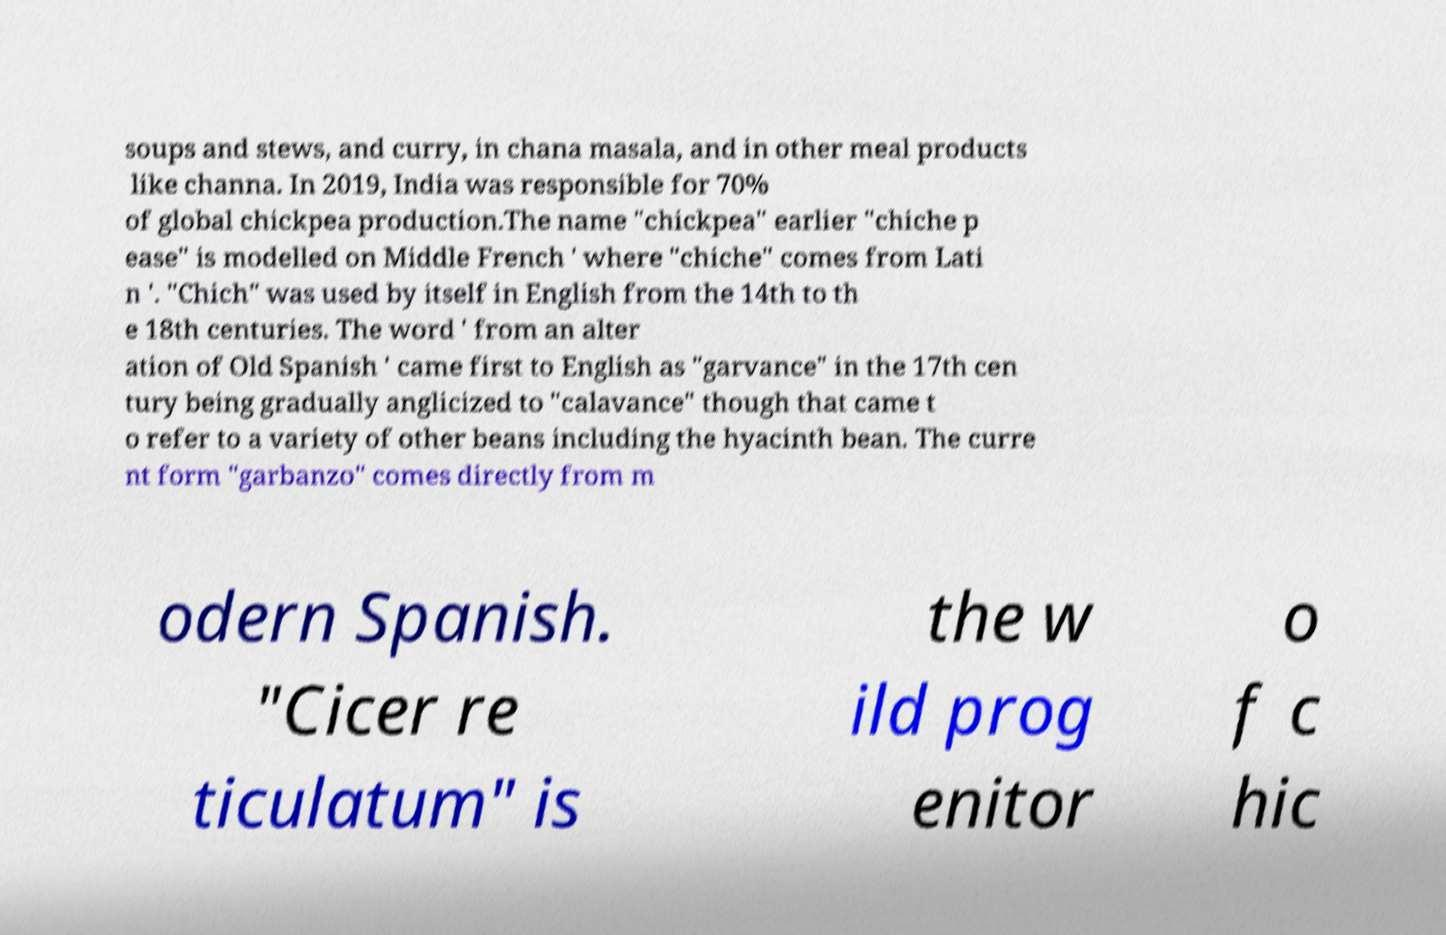Could you assist in decoding the text presented in this image and type it out clearly? soups and stews, and curry, in chana masala, and in other meal products like channa. In 2019, India was responsible for 70% of global chickpea production.The name "chickpea" earlier "chiche p ease" is modelled on Middle French ' where "chiche" comes from Lati n '. "Chich" was used by itself in English from the 14th to th e 18th centuries. The word ' from an alter ation of Old Spanish ' came first to English as "garvance" in the 17th cen tury being gradually anglicized to "calavance" though that came t o refer to a variety of other beans including the hyacinth bean. The curre nt form "garbanzo" comes directly from m odern Spanish. "Cicer re ticulatum" is the w ild prog enitor o f c hic 